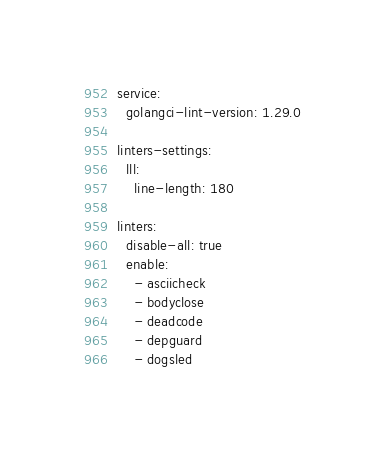<code> <loc_0><loc_0><loc_500><loc_500><_YAML_>service:
  golangci-lint-version: 1.29.0

linters-settings:
  lll:
    line-length: 180

linters:
  disable-all: true
  enable:
    - asciicheck
    - bodyclose
    - deadcode
    - depguard
    - dogsled</code> 